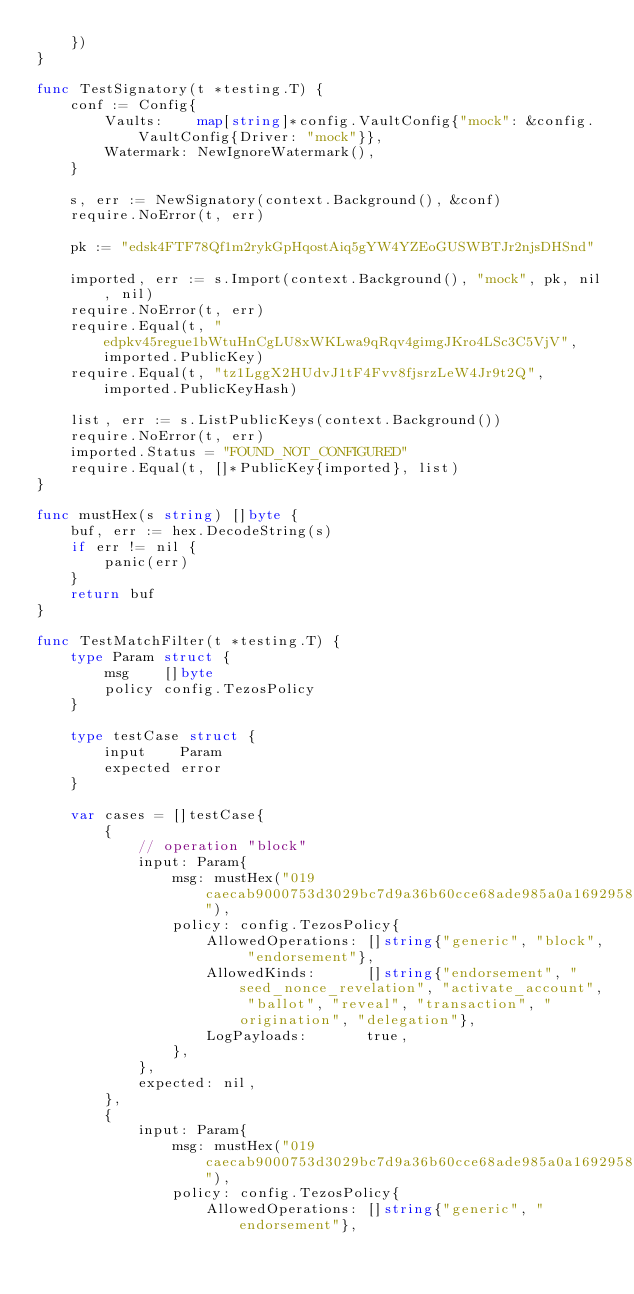<code> <loc_0><loc_0><loc_500><loc_500><_Go_>	})
}

func TestSignatory(t *testing.T) {
	conf := Config{
		Vaults:    map[string]*config.VaultConfig{"mock": &config.VaultConfig{Driver: "mock"}},
		Watermark: NewIgnoreWatermark(),
	}

	s, err := NewSignatory(context.Background(), &conf)
	require.NoError(t, err)

	pk := "edsk4FTF78Qf1m2rykGpHqostAiq5gYW4YZEoGUSWBTJr2njsDHSnd"

	imported, err := s.Import(context.Background(), "mock", pk, nil, nil)
	require.NoError(t, err)
	require.Equal(t, "edpkv45regue1bWtuHnCgLU8xWKLwa9qRqv4gimgJKro4LSc3C5VjV", imported.PublicKey)
	require.Equal(t, "tz1LggX2HUdvJ1tF4Fvv8fjsrzLeW4Jr9t2Q", imported.PublicKeyHash)

	list, err := s.ListPublicKeys(context.Background())
	require.NoError(t, err)
	imported.Status = "FOUND_NOT_CONFIGURED"
	require.Equal(t, []*PublicKey{imported}, list)
}

func mustHex(s string) []byte {
	buf, err := hex.DecodeString(s)
	if err != nil {
		panic(err)
	}
	return buf
}

func TestMatchFilter(t *testing.T) {
	type Param struct {
		msg    []byte
		policy config.TezosPolicy
	}

	type testCase struct {
		input    Param
		expected error
	}

	var cases = []testCase{
		{
			// operation "block"
			input: Param{
				msg: mustHex("019caecab9000753d3029bc7d9a36b60cce68ade985a0a16929587166e0d3de61efff2fa31b7116bf670000000005ee3c23b04519d71c4e54089c56773c44979b3ba3d61078ade40332ad81577ae074f653e0e0000001100000001010000000800000000000753d2da051ba81185783e4cbc633cf2ba809139ef07c3e5f6c5867f930e7667b224430000cde7fbbb948e030000"),
				policy: config.TezosPolicy{
					AllowedOperations: []string{"generic", "block", "endorsement"},
					AllowedKinds:      []string{"endorsement", "seed_nonce_revelation", "activate_account", "ballot", "reveal", "transaction", "origination", "delegation"},
					LogPayloads:       true,
				},
			},
			expected: nil,
		},
		{
			input: Param{
				msg: mustHex("019caecab9000753d3029bc7d9a36b60cce68ade985a0a16929587166e0d3de61efff2fa31b7116bf670000000005ee3c23b04519d71c4e54089c56773c44979b3ba3d61078ade40332ad81577ae074f653e0e0000001100000001010000000800000000000753d2da051ba81185783e4cbc633cf2ba809139ef07c3e5f6c5867f930e7667b224430000cde7fbbb948e030000"),
				policy: config.TezosPolicy{
					AllowedOperations: []string{"generic", "endorsement"},</code> 